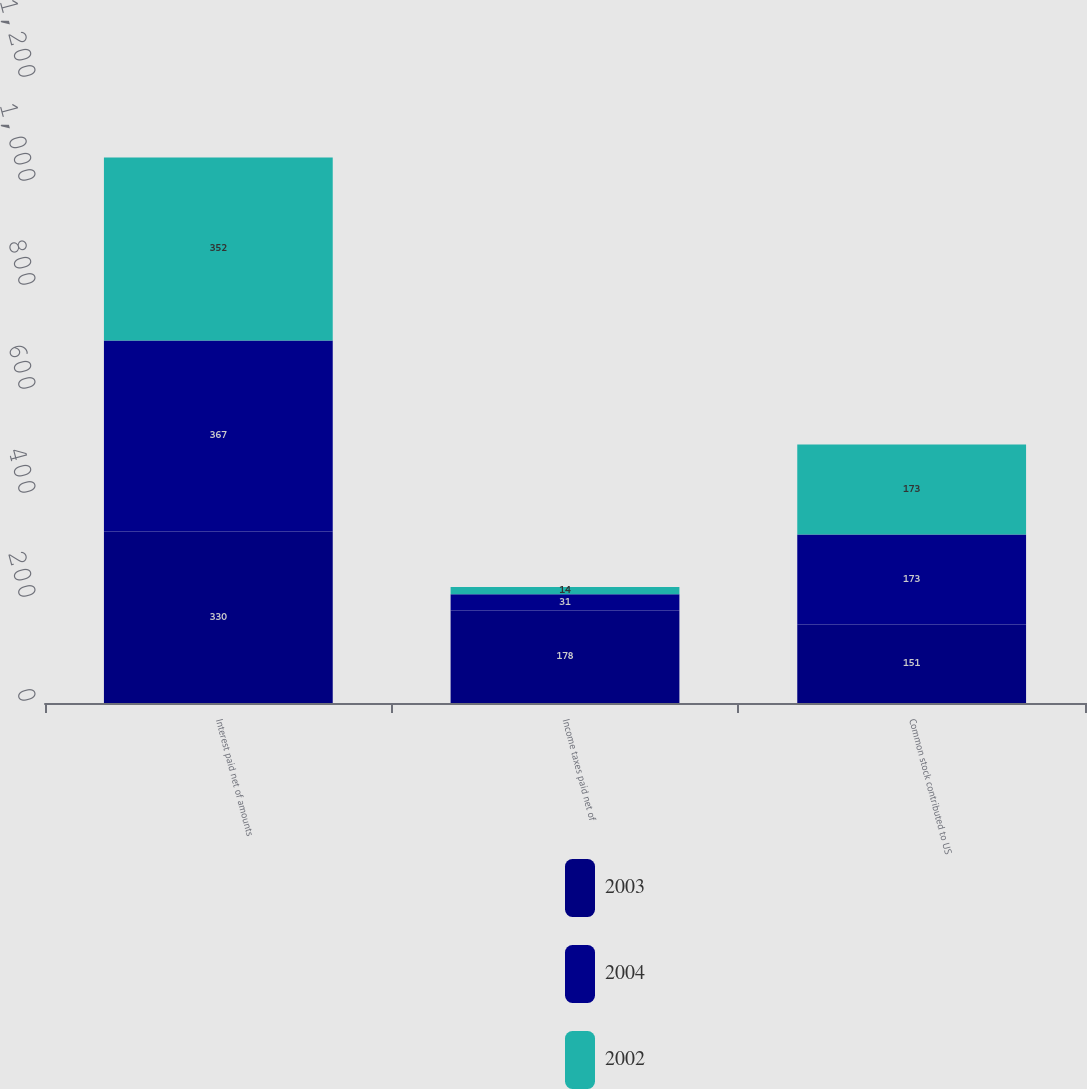Convert chart to OTSL. <chart><loc_0><loc_0><loc_500><loc_500><stacked_bar_chart><ecel><fcel>Interest paid net of amounts<fcel>Income taxes paid net of<fcel>Common stock contributed to US<nl><fcel>2003<fcel>330<fcel>178<fcel>151<nl><fcel>2004<fcel>367<fcel>31<fcel>173<nl><fcel>2002<fcel>352<fcel>14<fcel>173<nl></chart> 